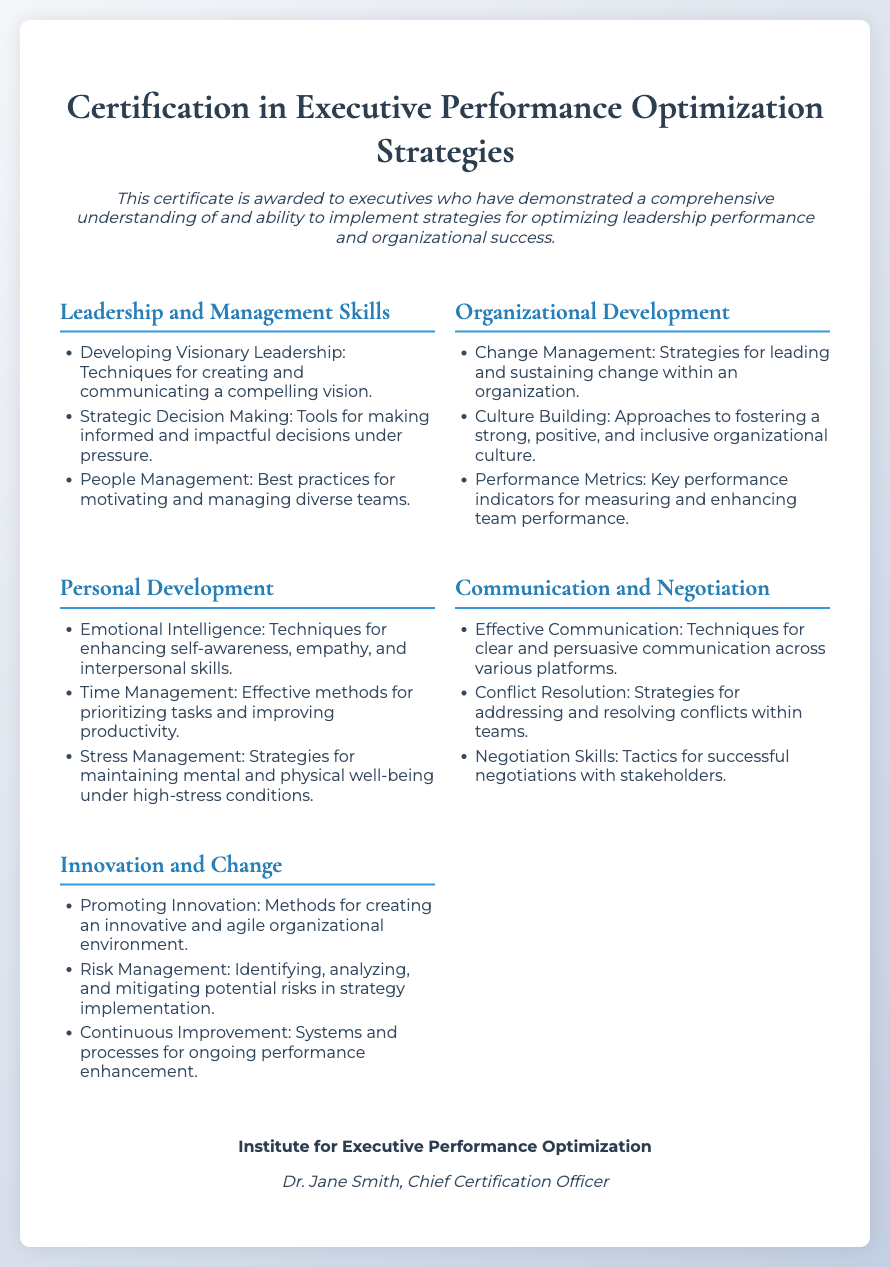what is the title of the certificate? The title appears prominently at the top of the certificate document.
Answer: Certification in Executive Performance Optimization Strategies who is the certifying body? The certifying body is stated in the footer section of the certificate.
Answer: Institute for Executive Performance Optimization who is the Chief Certification Officer? The name of the Chief Certification Officer is included in the footer section of the certificate.
Answer: Dr. Jane Smith how many sections are included in the content? The content consists of sections categorized under different themes, which can be counted in the document.
Answer: Five what is one strategy for managing stress mentioned? The document lists strategies for various personal development skills including stress management.
Answer: Strategies for maintaining mental and physical well-being under high-stress conditions which skill focuses on making informed decisions? The content outlines various leadership and management skills where one specifically mentions decision-making.
Answer: Strategic Decision Making what is a key performance indicator mentioned in the document? The section on organizational development includes references to measures for performance.
Answer: Key performance indicators for measuring and enhancing team performance which skill is associated with fostering a positive culture? The section dealing with organizational development outlines a relevant approach to culture.
Answer: Approaches to fostering a strong, positive, and inclusive organizational culture 